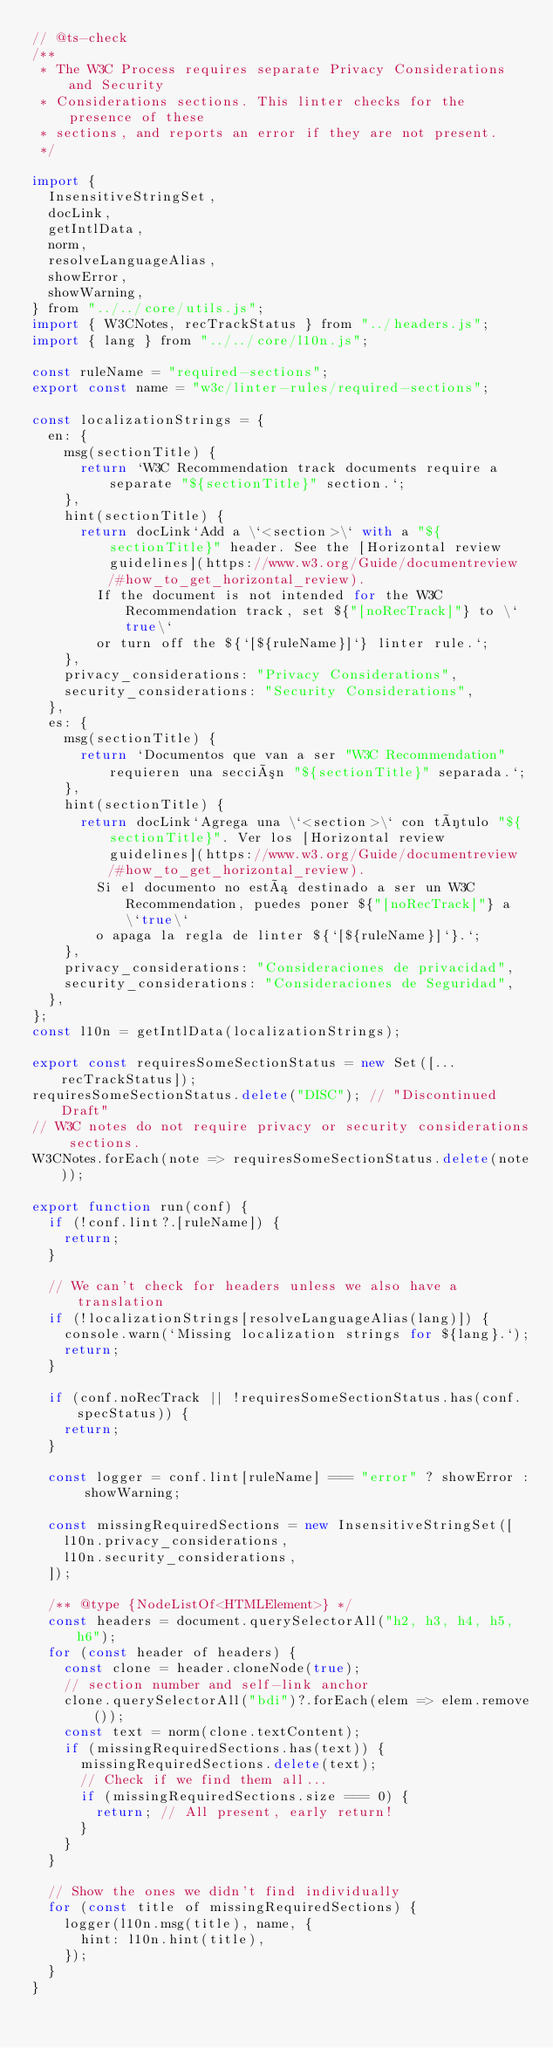Convert code to text. <code><loc_0><loc_0><loc_500><loc_500><_JavaScript_>// @ts-check
/**
 * The W3C Process requires separate Privacy Considerations and Security
 * Considerations sections. This linter checks for the presence of these
 * sections, and reports an error if they are not present.
 */

import {
  InsensitiveStringSet,
  docLink,
  getIntlData,
  norm,
  resolveLanguageAlias,
  showError,
  showWarning,
} from "../../core/utils.js";
import { W3CNotes, recTrackStatus } from "../headers.js";
import { lang } from "../../core/l10n.js";

const ruleName = "required-sections";
export const name = "w3c/linter-rules/required-sections";

const localizationStrings = {
  en: {
    msg(sectionTitle) {
      return `W3C Recommendation track documents require a separate "${sectionTitle}" section.`;
    },
    hint(sectionTitle) {
      return docLink`Add a \`<section>\` with a "${sectionTitle}" header. See the [Horizontal review guidelines](https://www.w3.org/Guide/documentreview/#how_to_get_horizontal_review).
        If the document is not intended for the W3C Recommendation track, set ${"[noRecTrack]"} to \`true\`
        or turn off the ${`[${ruleName}]`} linter rule.`;
    },
    privacy_considerations: "Privacy Considerations",
    security_considerations: "Security Considerations",
  },
  es: {
    msg(sectionTitle) {
      return `Documentos que van a ser "W3C Recommendation" requieren una sección "${sectionTitle}" separada.`;
    },
    hint(sectionTitle) {
      return docLink`Agrega una \`<section>\` con título "${sectionTitle}". Ver los [Horizontal review guidelines](https://www.w3.org/Guide/documentreview/#how_to_get_horizontal_review).
        Si el documento no está destinado a ser un W3C Recommendation, puedes poner ${"[noRecTrack]"} a \`true\`
        o apaga la regla de linter ${`[${ruleName}]`}.`;
    },
    privacy_considerations: "Consideraciones de privacidad",
    security_considerations: "Consideraciones de Seguridad",
  },
};
const l10n = getIntlData(localizationStrings);

export const requiresSomeSectionStatus = new Set([...recTrackStatus]);
requiresSomeSectionStatus.delete("DISC"); // "Discontinued Draft"
// W3C notes do not require privacy or security considerations sections.
W3CNotes.forEach(note => requiresSomeSectionStatus.delete(note));

export function run(conf) {
  if (!conf.lint?.[ruleName]) {
    return;
  }

  // We can't check for headers unless we also have a translation
  if (!localizationStrings[resolveLanguageAlias(lang)]) {
    console.warn(`Missing localization strings for ${lang}.`);
    return;
  }

  if (conf.noRecTrack || !requiresSomeSectionStatus.has(conf.specStatus)) {
    return;
  }

  const logger = conf.lint[ruleName] === "error" ? showError : showWarning;

  const missingRequiredSections = new InsensitiveStringSet([
    l10n.privacy_considerations,
    l10n.security_considerations,
  ]);

  /** @type {NodeListOf<HTMLElement>} */
  const headers = document.querySelectorAll("h2, h3, h4, h5, h6");
  for (const header of headers) {
    const clone = header.cloneNode(true);
    // section number and self-link anchor
    clone.querySelectorAll("bdi")?.forEach(elem => elem.remove());
    const text = norm(clone.textContent);
    if (missingRequiredSections.has(text)) {
      missingRequiredSections.delete(text);
      // Check if we find them all...
      if (missingRequiredSections.size === 0) {
        return; // All present, early return!
      }
    }
  }

  // Show the ones we didn't find individually
  for (const title of missingRequiredSections) {
    logger(l10n.msg(title), name, {
      hint: l10n.hint(title),
    });
  }
}
</code> 